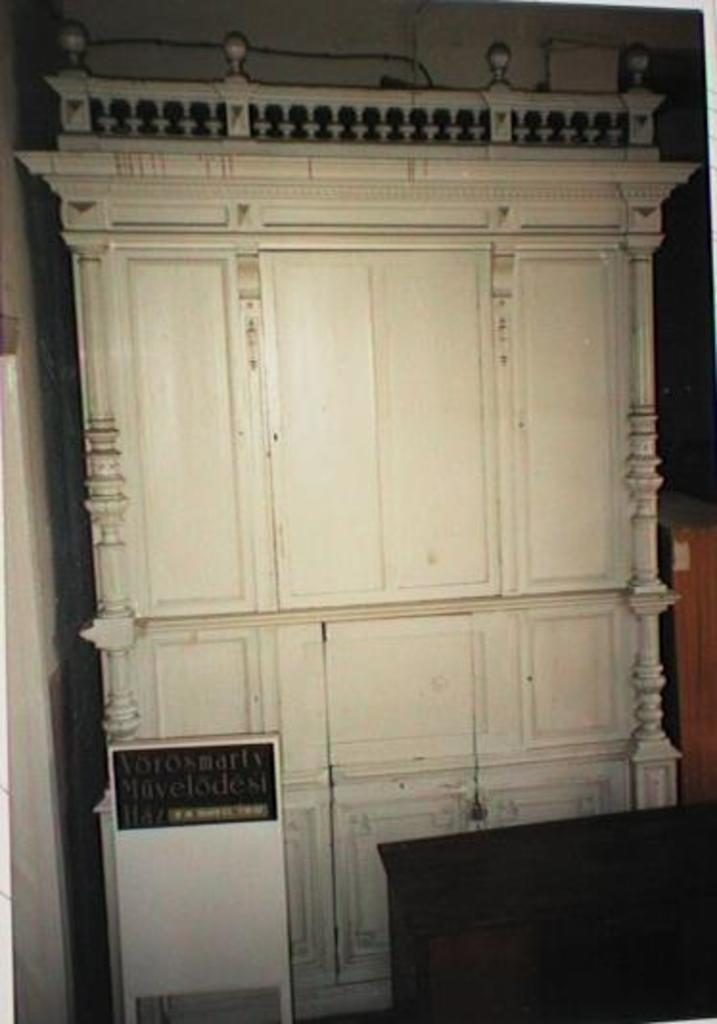What color is the cupboard in the image? The cupboard in the image is white. What can be seen on the board in the image? There is writing on the board in the image. What else can be seen on the right side of the image? There are other objects on the right side of the image. Is the cupboard made of glass in the image? No, the cupboard in the image is not made of glass; it is described as white. 